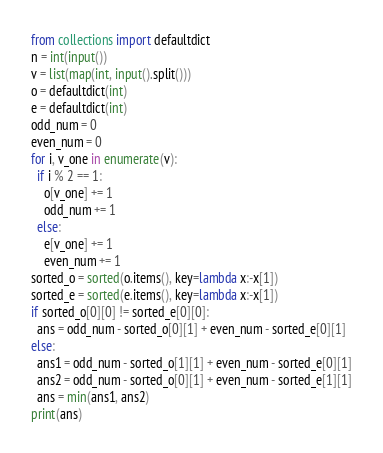Convert code to text. <code><loc_0><loc_0><loc_500><loc_500><_Python_>from collections import defaultdict
n = int(input())
v = list(map(int, input().split()))
o = defaultdict(int)
e = defaultdict(int)
odd_num = 0
even_num = 0
for i, v_one in enumerate(v):
  if i % 2 == 1:
    o[v_one] += 1
    odd_num += 1
  else:
    e[v_one] += 1
    even_num += 1
sorted_o = sorted(o.items(), key=lambda x:-x[1])
sorted_e = sorted(e.items(), key=lambda x:-x[1])
if sorted_o[0][0] != sorted_e[0][0]:
  ans = odd_num - sorted_o[0][1] + even_num - sorted_e[0][1]
else:
  ans1 = odd_num - sorted_o[1][1] + even_num - sorted_e[0][1]
  ans2 = odd_num - sorted_o[0][1] + even_num - sorted_e[1][1]
  ans = min(ans1, ans2)
print(ans)</code> 